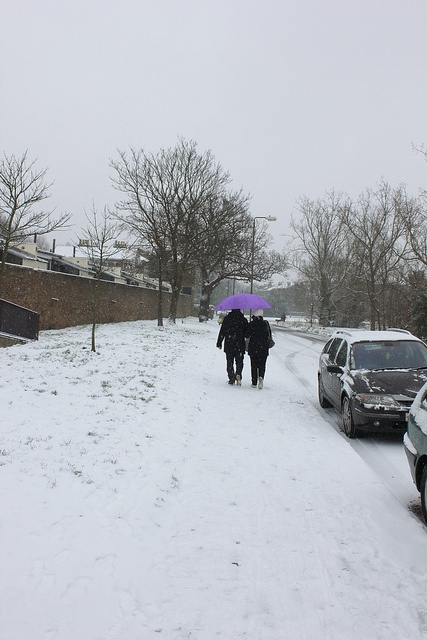Describe the objects in this image and their specific colors. I can see car in lightgray, gray, black, and darkgray tones, car in lightgray, gray, black, and darkgray tones, people in lightgray, black, gray, and darkgray tones, people in lightgray, black, gray, and darkgray tones, and umbrella in lightgray, magenta, purple, violet, and gray tones in this image. 